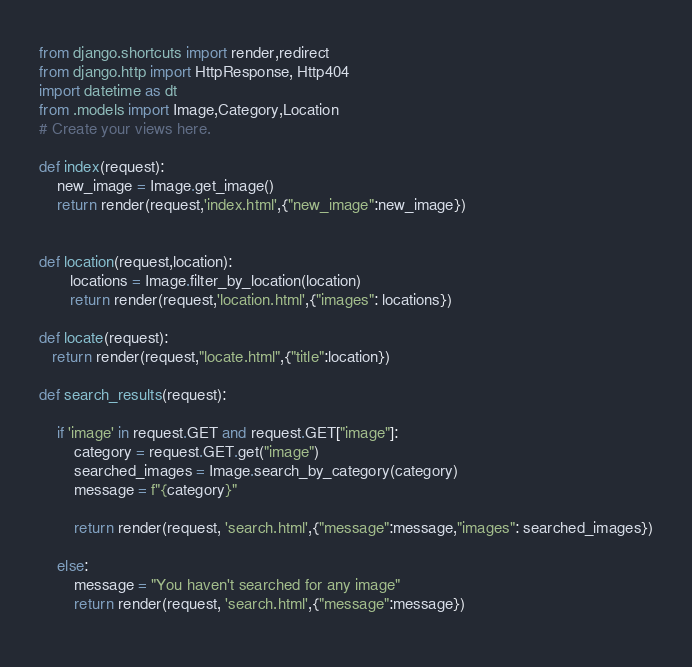<code> <loc_0><loc_0><loc_500><loc_500><_Python_>from django.shortcuts import render,redirect
from django.http import HttpResponse, Http404
import datetime as dt
from .models import Image,Category,Location
# Create your views here.

def index(request):
    new_image = Image.get_image()
    return render(request,'index.html',{"new_image":new_image})


def location(request,location):
       locations = Image.filter_by_location(location)
       return render(request,'location.html',{"images": locations})

def locate(request):
   return render(request,"locate.html",{"title":location})

def search_results(request):

    if 'image' in request.GET and request.GET["image"]:
        category = request.GET.get("image")
        searched_images = Image.search_by_category(category)
        message = f"{category}"

        return render(request, 'search.html',{"message":message,"images": searched_images})

    else:
        message = "You haven't searched for any image"
        return render(request, 'search.html',{"message":message})     
   </code> 